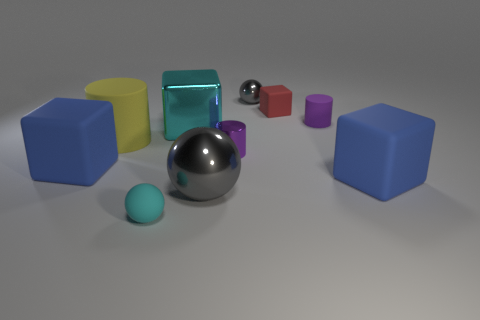Subtract all large gray metallic balls. How many balls are left? 2 Add 1 metal spheres. How many metal spheres are left? 3 Add 3 gray metallic blocks. How many gray metallic blocks exist? 3 Subtract all cyan balls. How many balls are left? 2 Subtract 1 red blocks. How many objects are left? 9 Subtract all cubes. How many objects are left? 6 Subtract 1 cubes. How many cubes are left? 3 Subtract all green blocks. Subtract all cyan cylinders. How many blocks are left? 4 Subtract all brown cylinders. How many green cubes are left? 0 Subtract all rubber cubes. Subtract all cyan things. How many objects are left? 5 